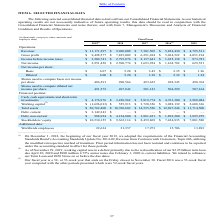Looking at Adobe Systems's financial data, please calculate: What was the gross profit margin in 2018? Based on the calculation: 7,835,009/9,030,008, the result is 86.77 (percentage). This is based on the information: "Revenue: $ 11,171,297 $ 9,030,008 $ 7,301,505 $ 5,854,430 $ 4,795,511 Gross profit $ 9,498,577 $ 7,835,009 $ 6,291,014 $ 5,034,522 $ 4,051,194..." The key data points involved are: 7,835,009, 9,030,008. Also, Why was the working capital negative in 2019? working capital was in a deficit primarily due to the reclassification of our $2.25 billion term loan due April 30, 2020 and $900 million 4.75% senior notes due February 1, 2020 to current liabilities.. The document states: "(2) As of November 29, 2019, working capital was in a deficit primarily due to the reclassification of our $2.25 billion term loan due April 30, 2020 ..." Also, can you calculate: What is the total liabilities of the company in 2019? Based on the calculation: 3,149,343 + 988,924, the result is 4138267 (in thousands). This is based on the information: "Debt, non-current $ 988,924 $ 4,124,800 $ 1,881,421 $ 1,892,200 $ 1,895,259 Debt, current $ 3,149,343 $ — $ — $ — $ —..." The key data points involved are: 3,149,343, 988,924. Also, can you calculate: What was the total net income of basic shares in 2019? Based on the calculation: 486,291 * $6.07, the result is 2951786.37. This is based on the information: "Basic $ 6.07 $ 5.28 $ 3.43 $ 2.35 $ 1.26 Shares used to compute basic net income per share 486,291 490,564 493,632 498,345 498,764..." The key data points involved are: 486,291, 6.07. Also, What type is the year 2016, 52-week or 53-week? According to the financial document, 53-week. The relevant text states: "(3) Our fiscal year is a 52- or 53-week year that ends on the Friday closest to November 30. Fiscal 2016 was a 53-week fiscal year compared (3) Our fiscal year is a 52- or 53-week year that ends on th..." Also, When did the company adopt the requirements of the Financial Accounting Standards Board's Accounting Standards Update No. 2014-09, Revenue from Contracts with Customers, Topic 606, utilizing the modified retrospective method of transition? According to the financial document, December 1, 2018. The relevant text states: "(1) On December 1, 2018, the beginning of our fiscal year 2019, we adopted the requirements of the Financial Accounting Sta..." 